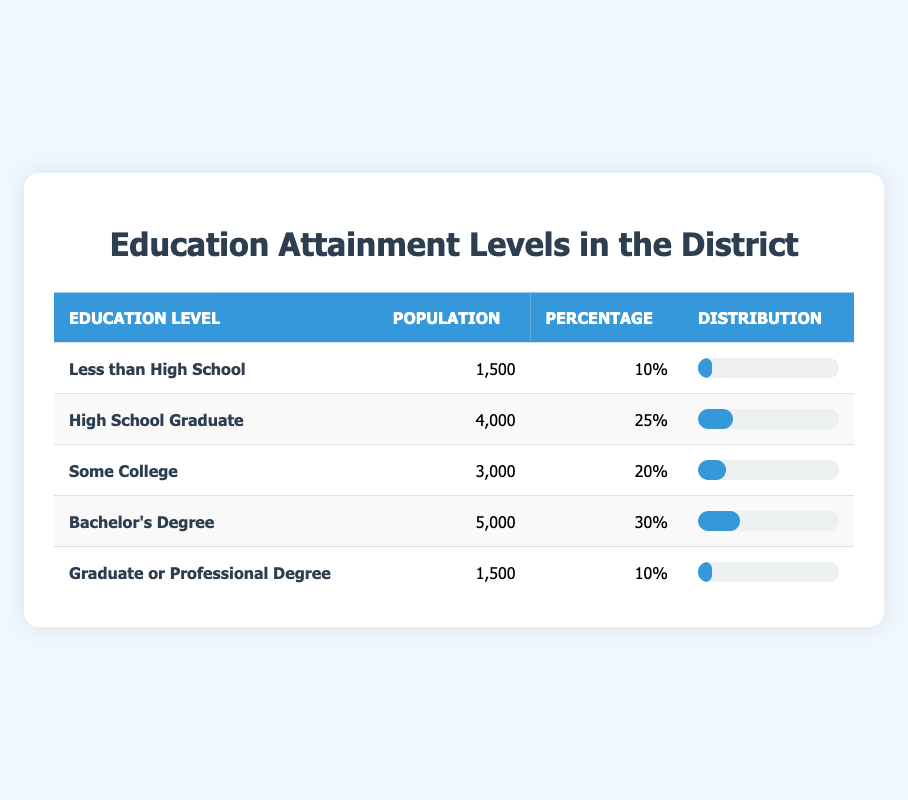What percentage of the population has a Bachelor's Degree? The table shows that the population with a Bachelor's Degree is represented by the Percentage column. The entry for Bachelor's Degree indicates that 30% of the population falls into this category.
Answer: 30 How many people have attained a High School Graduate level of education? Referring to the Population column in the table, the row for High School Graduate shows a population of 4,000 individuals.
Answer: 4000 Is the population with a Graduate or Professional Degree greater than the population with a High School Graduate? To answer this, we compare the respective populations listed in the table. The Graduate or Professional Degree population is 1,500, whereas the High School Graduate population is 4,000. Since 1,500 is not greater than 4,000, the statement is false.
Answer: No What is the total population of individuals with education levels below a Bachelor's Degree? We need to sum the populations of the first three levels: Less than High School (1,500) + High School Graduate (4,000) + Some College (3,000). Adding these gives 1,500 + 4,000 + 3,000 = 8,500 individuals.
Answer: 8500 What is the percentage of the population that has less than a High School education compared to those that have at least a Bachelor’s Degree? From the table, 10% of the population has less than a High School education, and 30% have a Bachelor’s Degree. We classify those with Bachelor's or higher as those with either a Bachelor's Degree (30%) or a Graduate/Professional Degree (10%), totaling 40%. Then, comparing 10% to 40% shows that 10% is 25% of 40% (calculated as 10% / 40% = 0.25).
Answer: 25% 